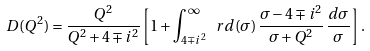<formula> <loc_0><loc_0><loc_500><loc_500>D ( Q ^ { 2 } ) = \frac { Q ^ { 2 } } { Q ^ { 2 } + 4 \mp i ^ { 2 } } \left [ 1 + \int _ { 4 \mp i ^ { 2 } } ^ { \infty } \ r d ( \sigma ) \, \frac { \sigma - 4 \mp i ^ { 2 } } { \sigma + Q ^ { 2 } } \, \frac { d \sigma } { \sigma } \right ] .</formula> 